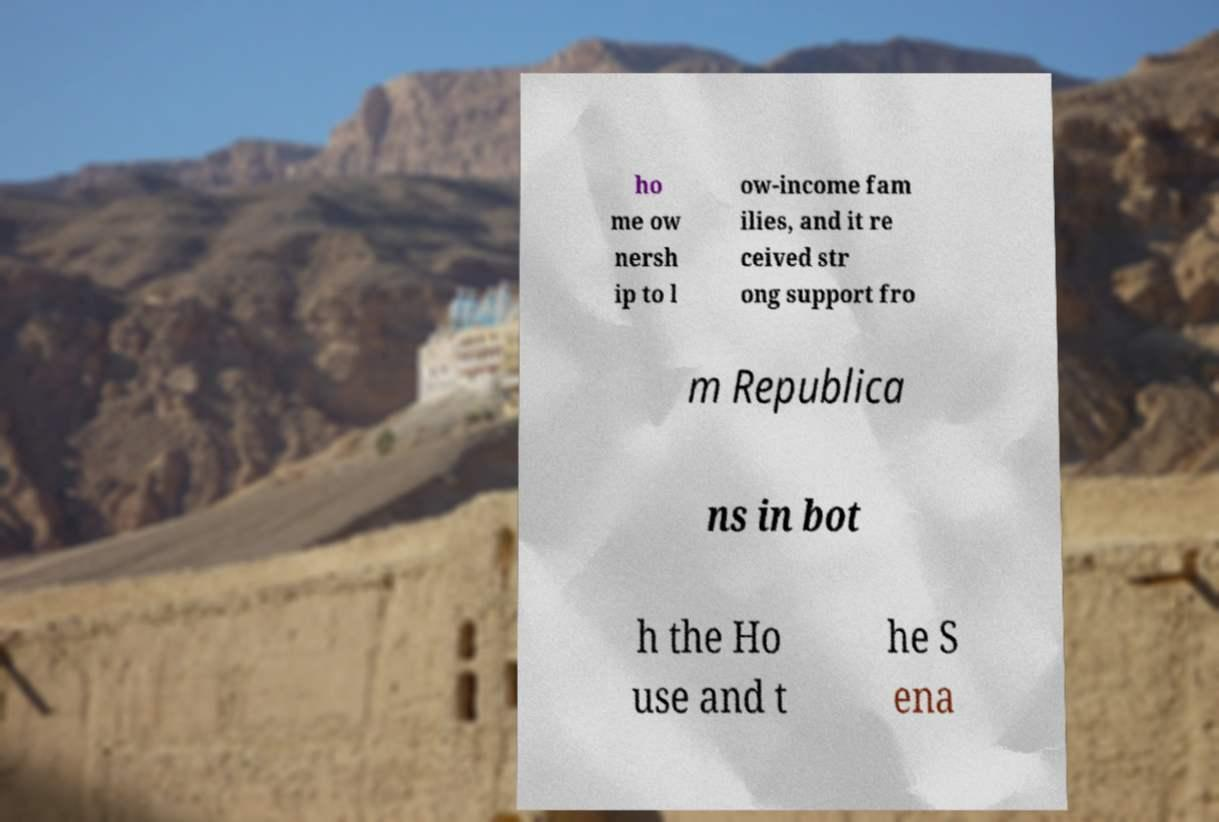For documentation purposes, I need the text within this image transcribed. Could you provide that? ho me ow nersh ip to l ow-income fam ilies, and it re ceived str ong support fro m Republica ns in bot h the Ho use and t he S ena 